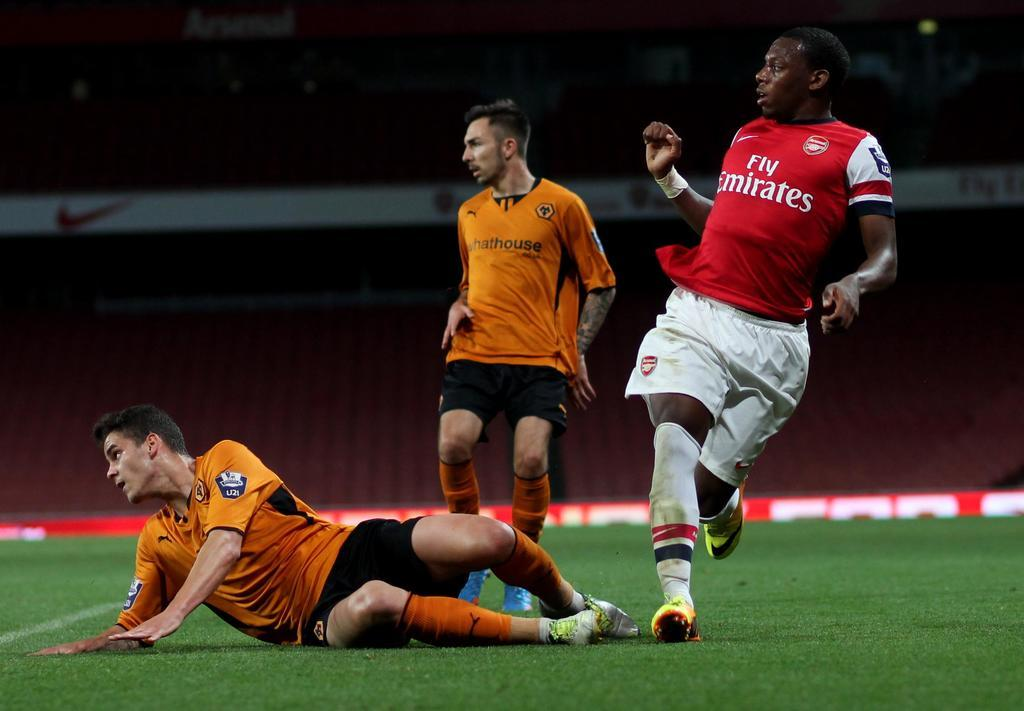<image>
Offer a succinct explanation of the picture presented. Three players on the field and the player with the Emirates jersey looks like he sees something in front of him. 